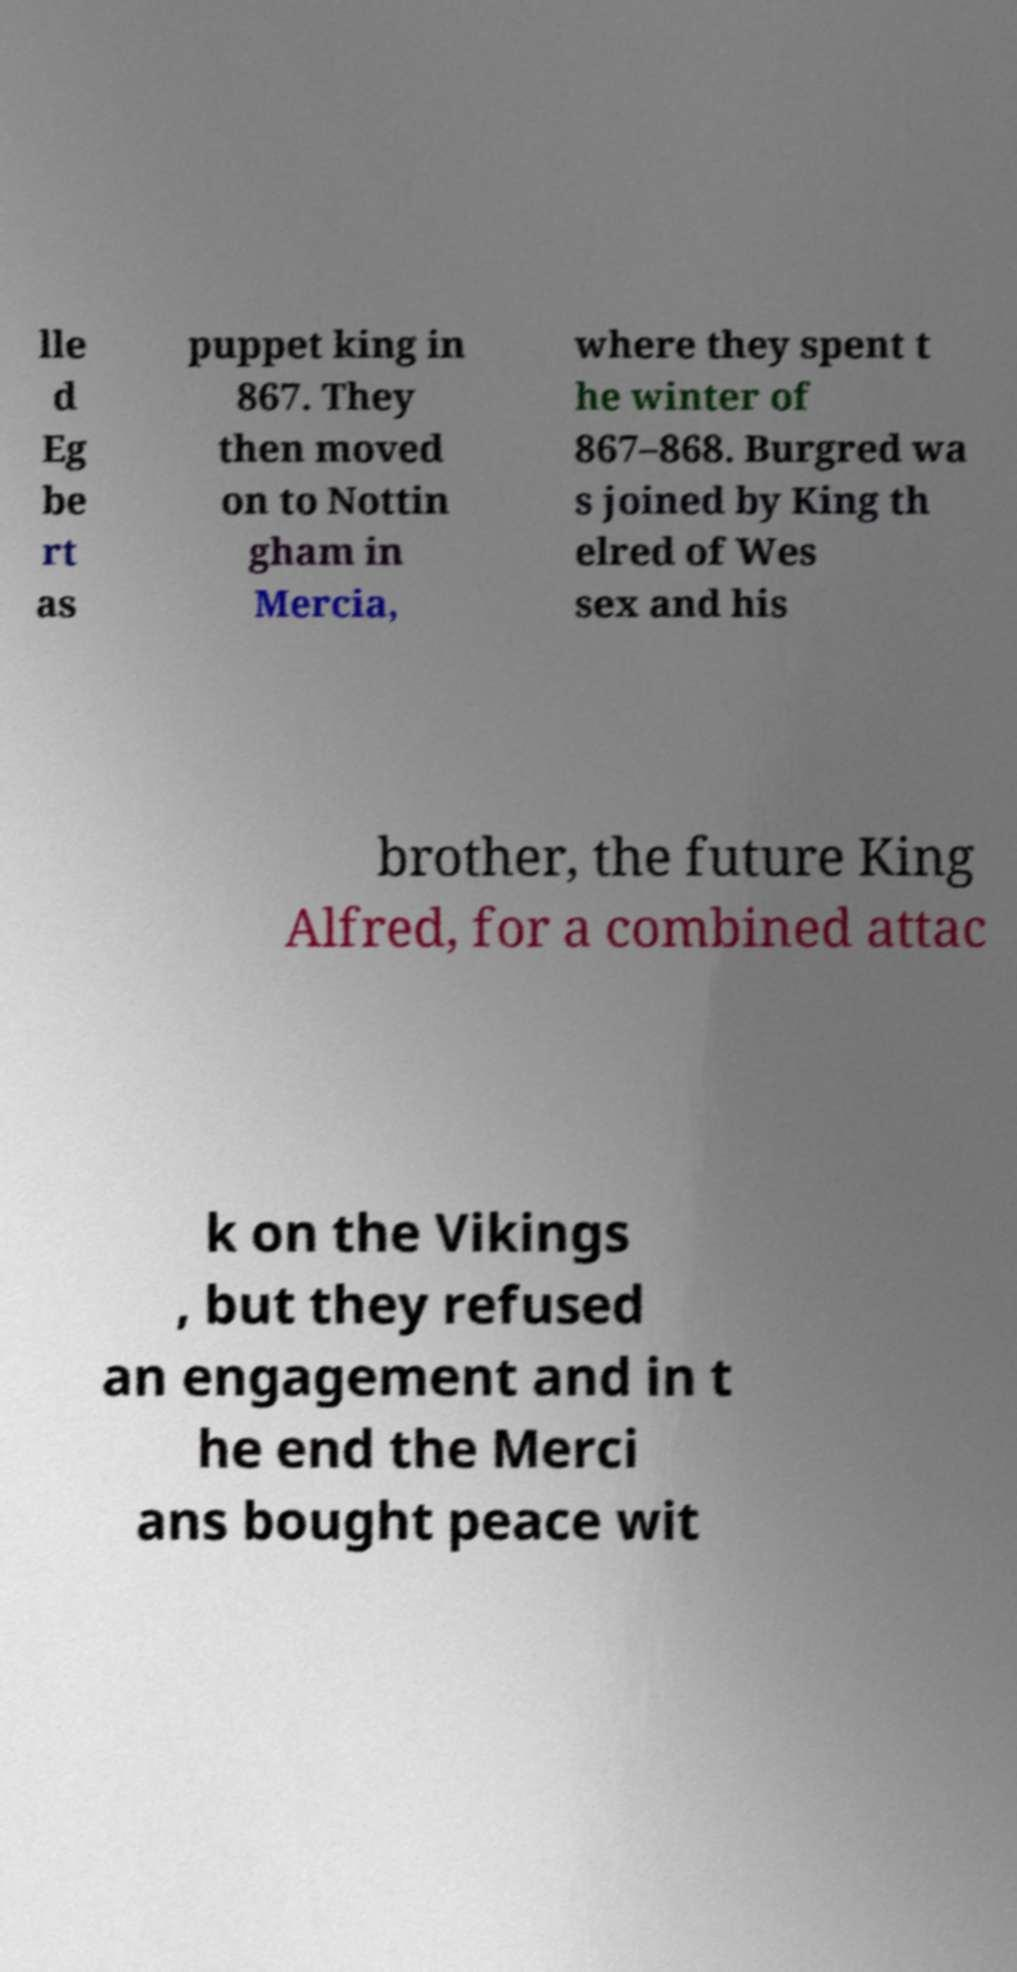Can you accurately transcribe the text from the provided image for me? lle d Eg be rt as puppet king in 867. They then moved on to Nottin gham in Mercia, where they spent t he winter of 867–868. Burgred wa s joined by King th elred of Wes sex and his brother, the future King Alfred, for a combined attac k on the Vikings , but they refused an engagement and in t he end the Merci ans bought peace wit 